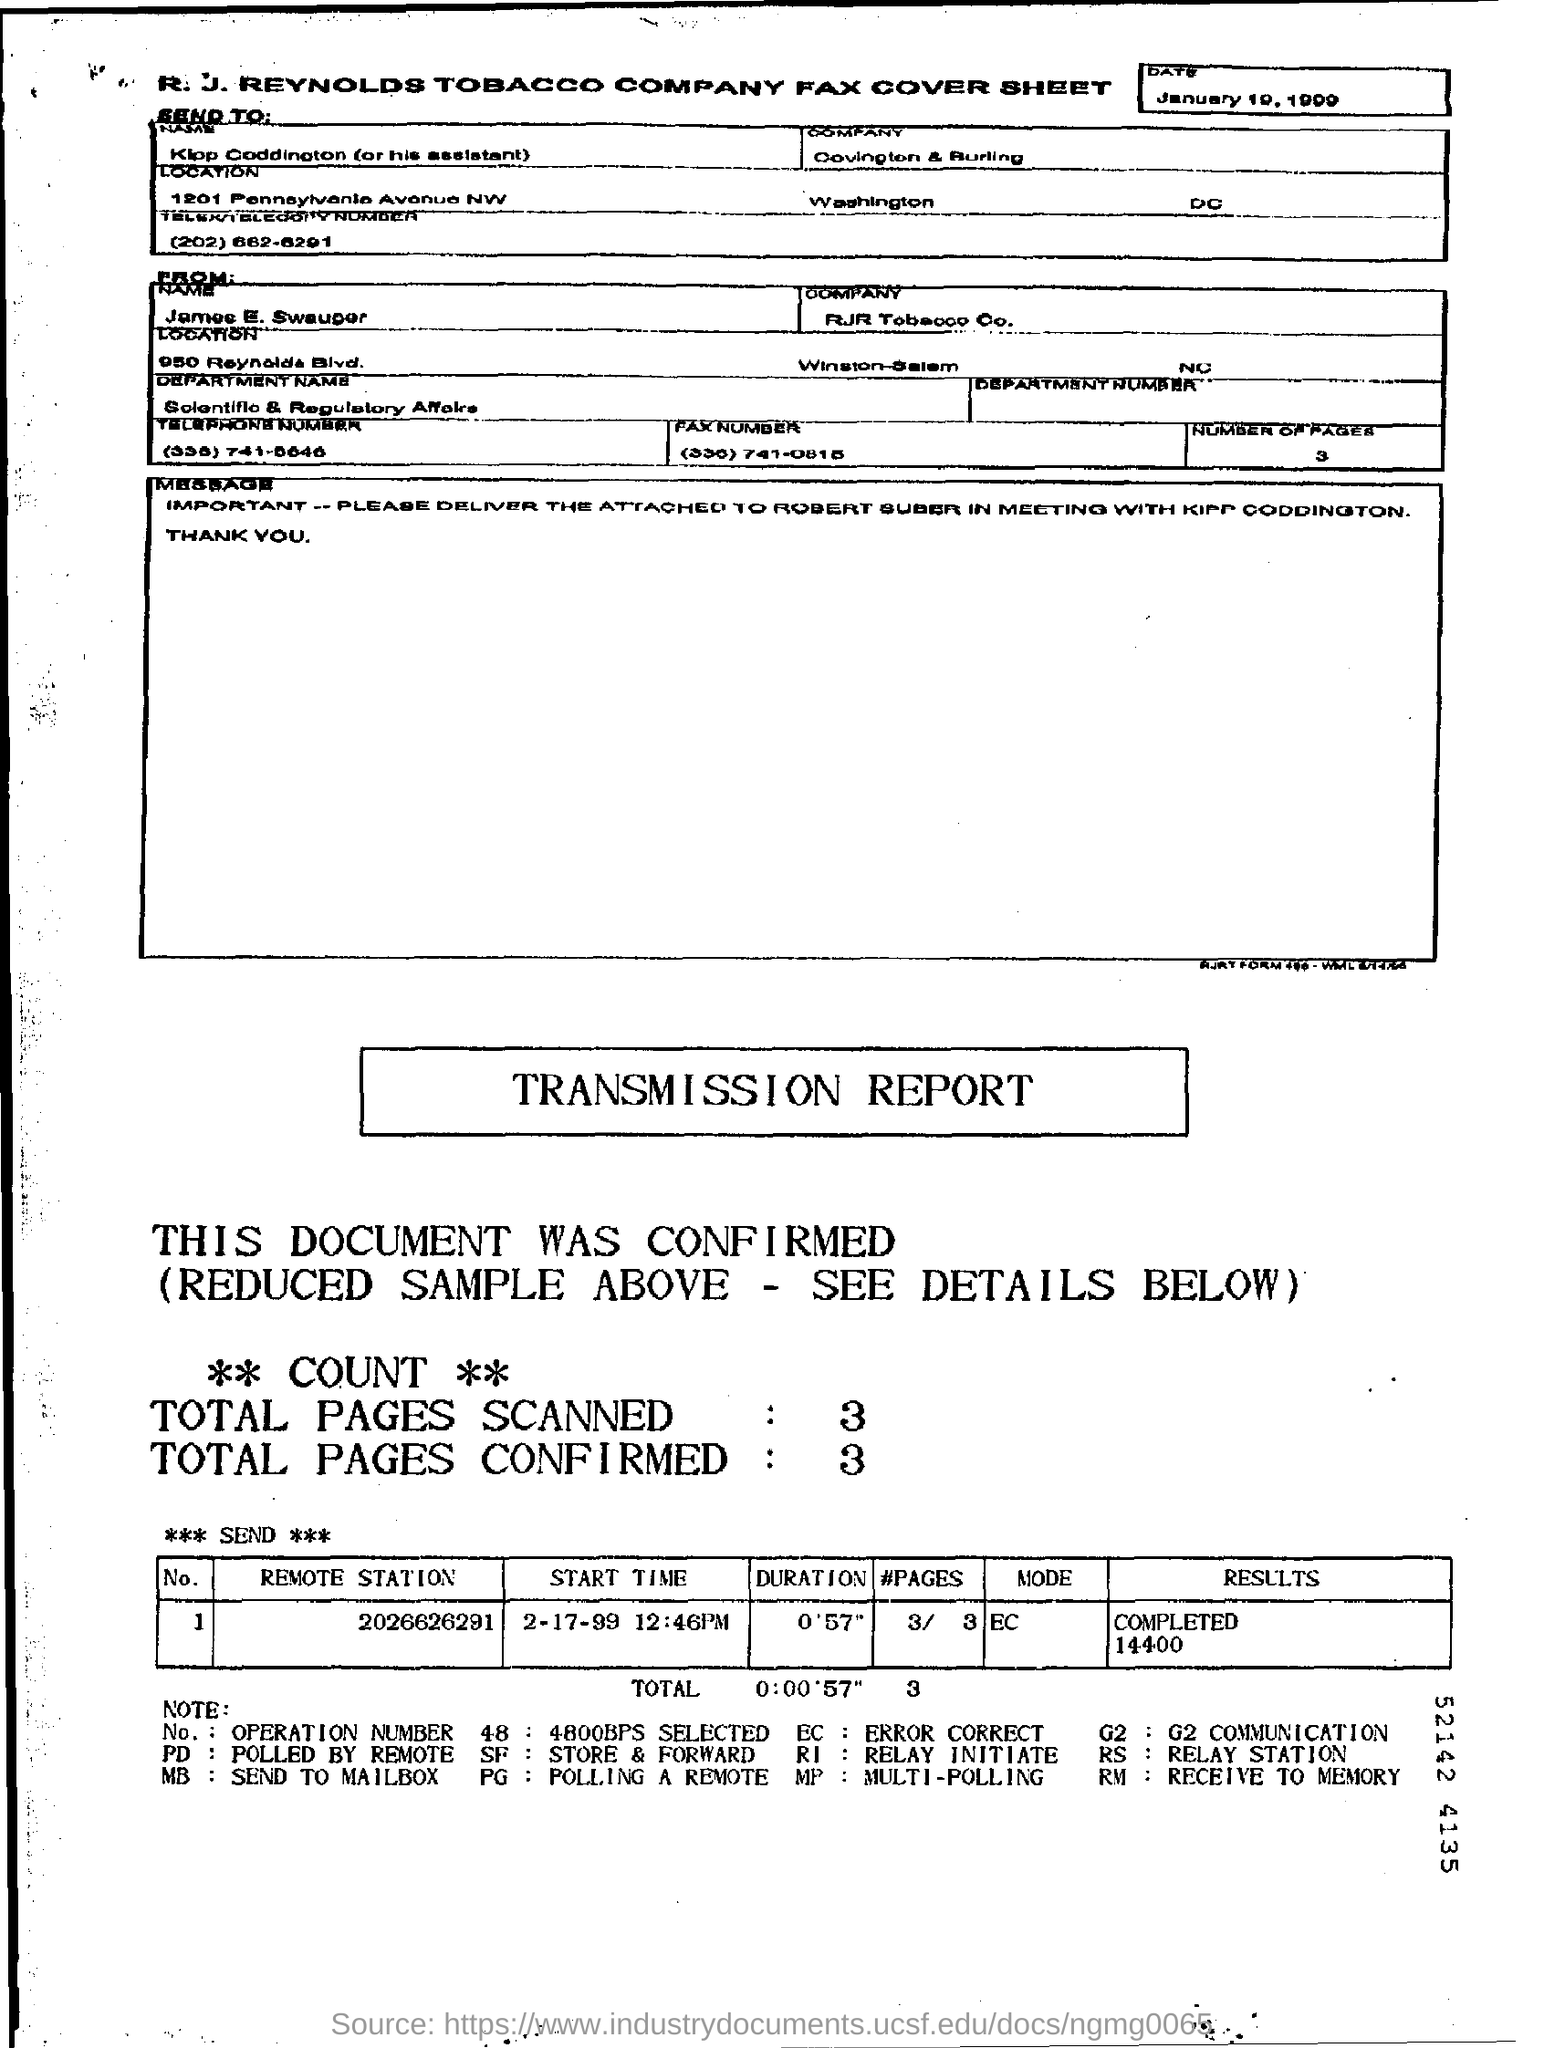Mention a couple of crucial points in this snapshot. The start time for the remote station with the number 2026626291 is February 17th, 1999 at 12:46 PM. The total number of pages scanned is 3.. The fax is addressed to Covington & Burling. The duration for the remote station with the number 2026626291 is 57 seconds. The total number of pages confirmed is three. 